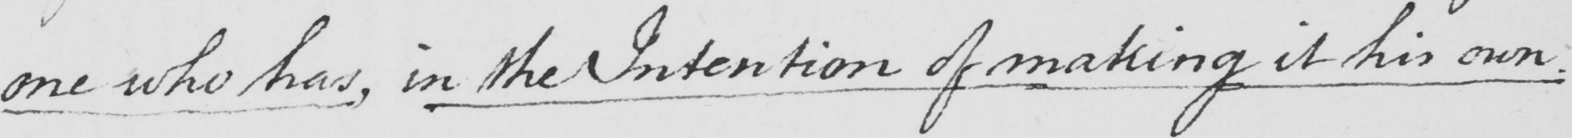What text is written in this handwritten line? one who has , in the Intention of making it his own . 